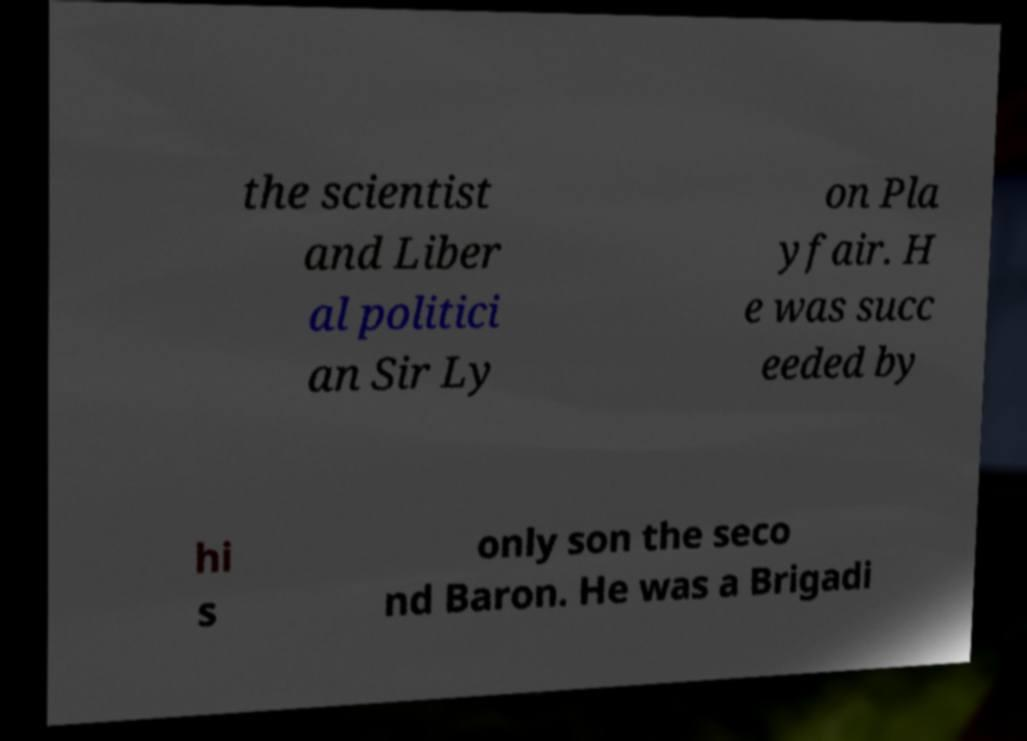There's text embedded in this image that I need extracted. Can you transcribe it verbatim? the scientist and Liber al politici an Sir Ly on Pla yfair. H e was succ eeded by hi s only son the seco nd Baron. He was a Brigadi 